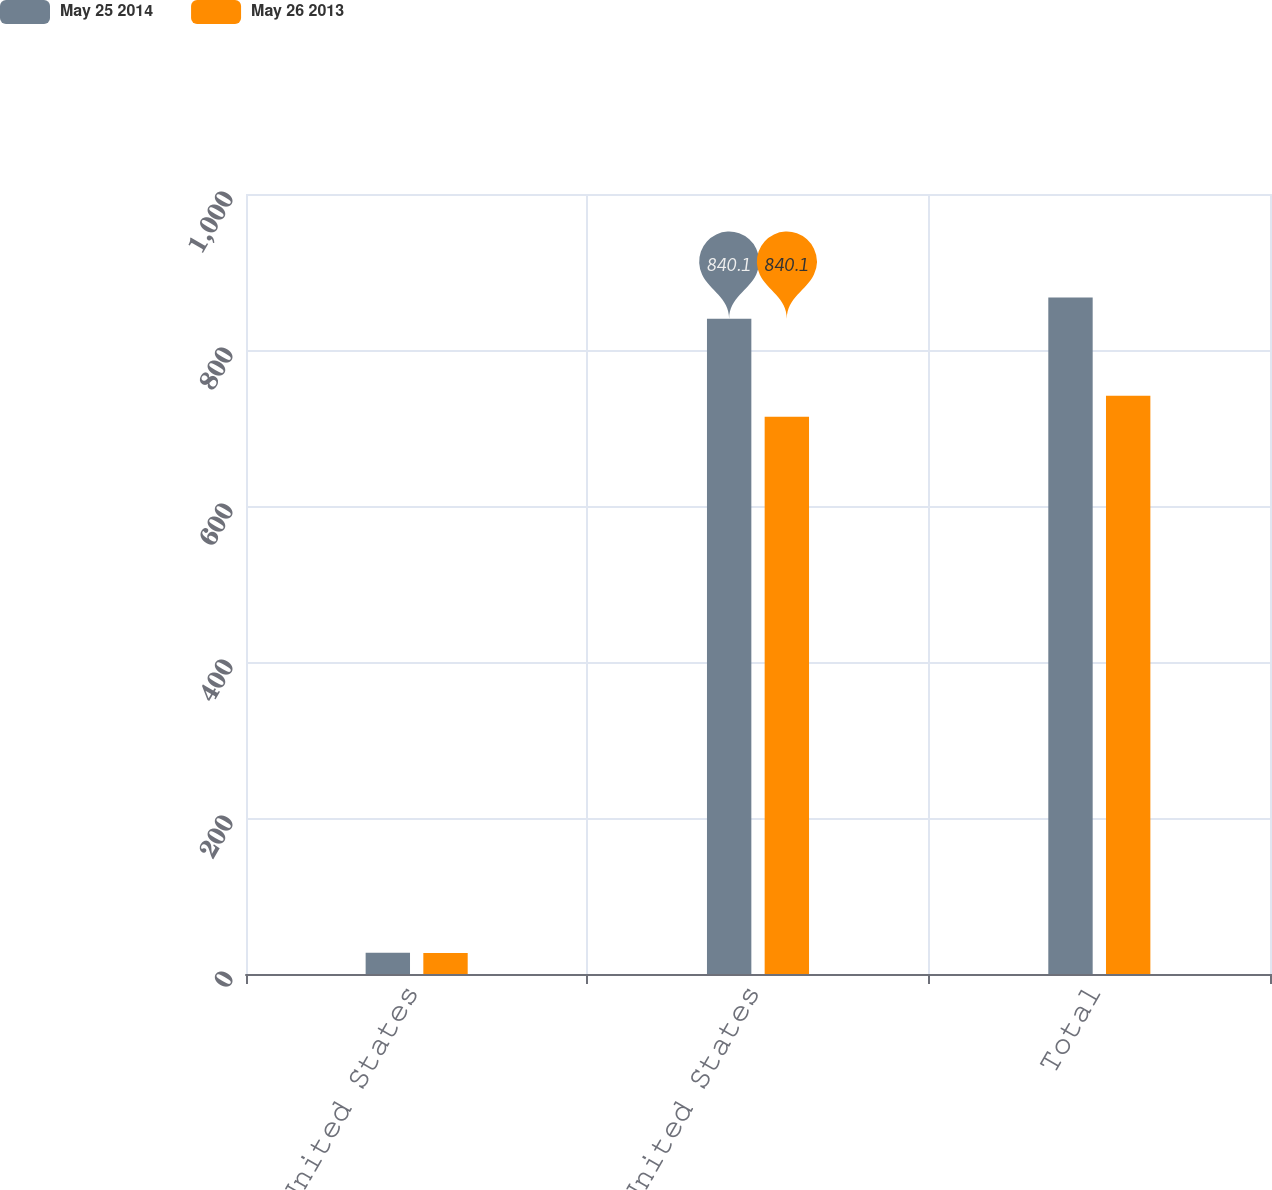Convert chart. <chart><loc_0><loc_0><loc_500><loc_500><stacked_bar_chart><ecel><fcel>United States<fcel>Non-United States<fcel>Total<nl><fcel>May 25 2014<fcel>27.2<fcel>840.1<fcel>867.3<nl><fcel>May 26 2013<fcel>26.9<fcel>714.5<fcel>741.4<nl></chart> 